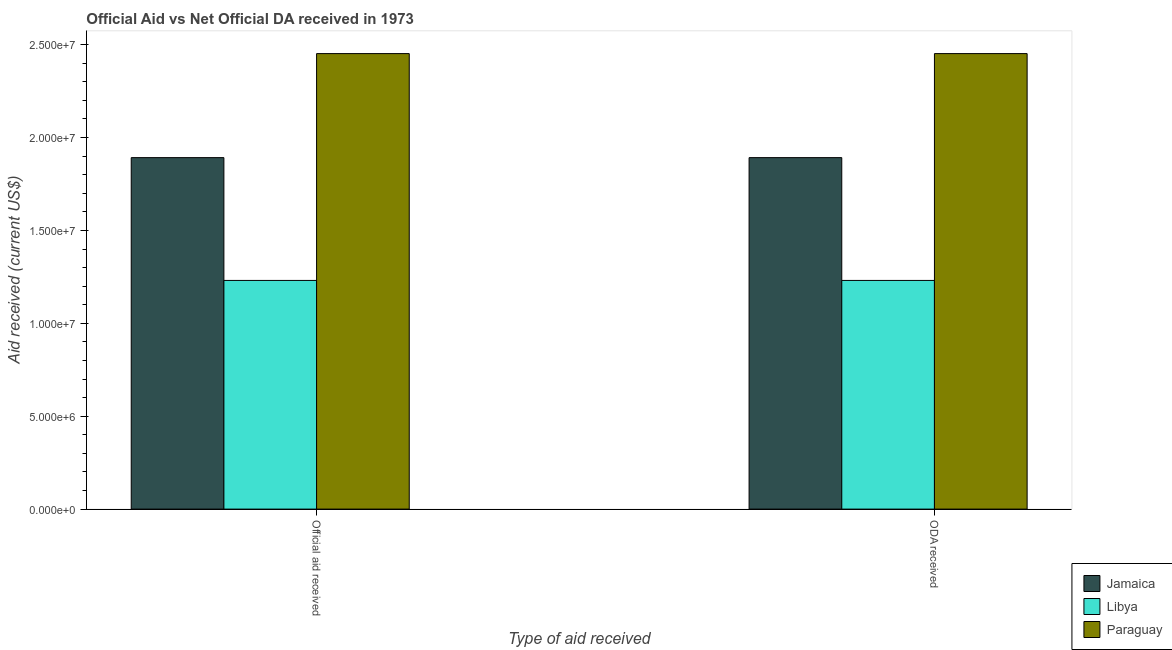How many different coloured bars are there?
Provide a succinct answer. 3. Are the number of bars per tick equal to the number of legend labels?
Your answer should be very brief. Yes. How many bars are there on the 2nd tick from the left?
Offer a terse response. 3. How many bars are there on the 2nd tick from the right?
Offer a very short reply. 3. What is the label of the 1st group of bars from the left?
Offer a very short reply. Official aid received. What is the oda received in Paraguay?
Provide a succinct answer. 2.45e+07. Across all countries, what is the maximum oda received?
Make the answer very short. 2.45e+07. Across all countries, what is the minimum official aid received?
Offer a terse response. 1.23e+07. In which country was the official aid received maximum?
Offer a very short reply. Paraguay. In which country was the official aid received minimum?
Provide a succinct answer. Libya. What is the total oda received in the graph?
Your response must be concise. 5.58e+07. What is the difference between the oda received in Jamaica and that in Paraguay?
Provide a short and direct response. -5.60e+06. What is the difference between the official aid received in Libya and the oda received in Paraguay?
Your answer should be very brief. -1.22e+07. What is the average official aid received per country?
Your response must be concise. 1.86e+07. What is the ratio of the oda received in Paraguay to that in Jamaica?
Your answer should be very brief. 1.3. In how many countries, is the oda received greater than the average oda received taken over all countries?
Provide a succinct answer. 2. What does the 2nd bar from the left in Official aid received represents?
Your response must be concise. Libya. What does the 3rd bar from the right in ODA received represents?
Ensure brevity in your answer.  Jamaica. How many bars are there?
Provide a short and direct response. 6. How many countries are there in the graph?
Give a very brief answer. 3. Does the graph contain grids?
Provide a succinct answer. No. Where does the legend appear in the graph?
Make the answer very short. Bottom right. What is the title of the graph?
Ensure brevity in your answer.  Official Aid vs Net Official DA received in 1973 . What is the label or title of the X-axis?
Keep it short and to the point. Type of aid received. What is the label or title of the Y-axis?
Your response must be concise. Aid received (current US$). What is the Aid received (current US$) in Jamaica in Official aid received?
Your answer should be very brief. 1.89e+07. What is the Aid received (current US$) of Libya in Official aid received?
Ensure brevity in your answer.  1.23e+07. What is the Aid received (current US$) of Paraguay in Official aid received?
Make the answer very short. 2.45e+07. What is the Aid received (current US$) of Jamaica in ODA received?
Your answer should be very brief. 1.89e+07. What is the Aid received (current US$) in Libya in ODA received?
Your answer should be very brief. 1.23e+07. What is the Aid received (current US$) in Paraguay in ODA received?
Make the answer very short. 2.45e+07. Across all Type of aid received, what is the maximum Aid received (current US$) of Jamaica?
Give a very brief answer. 1.89e+07. Across all Type of aid received, what is the maximum Aid received (current US$) of Libya?
Offer a very short reply. 1.23e+07. Across all Type of aid received, what is the maximum Aid received (current US$) in Paraguay?
Provide a succinct answer. 2.45e+07. Across all Type of aid received, what is the minimum Aid received (current US$) in Jamaica?
Offer a terse response. 1.89e+07. Across all Type of aid received, what is the minimum Aid received (current US$) of Libya?
Give a very brief answer. 1.23e+07. Across all Type of aid received, what is the minimum Aid received (current US$) in Paraguay?
Provide a succinct answer. 2.45e+07. What is the total Aid received (current US$) of Jamaica in the graph?
Provide a short and direct response. 3.78e+07. What is the total Aid received (current US$) of Libya in the graph?
Give a very brief answer. 2.46e+07. What is the total Aid received (current US$) in Paraguay in the graph?
Ensure brevity in your answer.  4.90e+07. What is the difference between the Aid received (current US$) in Jamaica in Official aid received and the Aid received (current US$) in Libya in ODA received?
Your answer should be compact. 6.61e+06. What is the difference between the Aid received (current US$) of Jamaica in Official aid received and the Aid received (current US$) of Paraguay in ODA received?
Your response must be concise. -5.60e+06. What is the difference between the Aid received (current US$) of Libya in Official aid received and the Aid received (current US$) of Paraguay in ODA received?
Keep it short and to the point. -1.22e+07. What is the average Aid received (current US$) of Jamaica per Type of aid received?
Provide a succinct answer. 1.89e+07. What is the average Aid received (current US$) of Libya per Type of aid received?
Your answer should be compact. 1.23e+07. What is the average Aid received (current US$) of Paraguay per Type of aid received?
Provide a succinct answer. 2.45e+07. What is the difference between the Aid received (current US$) in Jamaica and Aid received (current US$) in Libya in Official aid received?
Provide a succinct answer. 6.61e+06. What is the difference between the Aid received (current US$) in Jamaica and Aid received (current US$) in Paraguay in Official aid received?
Ensure brevity in your answer.  -5.60e+06. What is the difference between the Aid received (current US$) of Libya and Aid received (current US$) of Paraguay in Official aid received?
Give a very brief answer. -1.22e+07. What is the difference between the Aid received (current US$) of Jamaica and Aid received (current US$) of Libya in ODA received?
Offer a terse response. 6.61e+06. What is the difference between the Aid received (current US$) in Jamaica and Aid received (current US$) in Paraguay in ODA received?
Keep it short and to the point. -5.60e+06. What is the difference between the Aid received (current US$) of Libya and Aid received (current US$) of Paraguay in ODA received?
Give a very brief answer. -1.22e+07. What is the ratio of the Aid received (current US$) of Jamaica in Official aid received to that in ODA received?
Ensure brevity in your answer.  1. What is the ratio of the Aid received (current US$) in Libya in Official aid received to that in ODA received?
Provide a short and direct response. 1. What is the ratio of the Aid received (current US$) of Paraguay in Official aid received to that in ODA received?
Provide a short and direct response. 1. What is the difference between the highest and the second highest Aid received (current US$) in Libya?
Provide a succinct answer. 0. What is the difference between the highest and the lowest Aid received (current US$) of Jamaica?
Your answer should be compact. 0. What is the difference between the highest and the lowest Aid received (current US$) in Paraguay?
Offer a terse response. 0. 